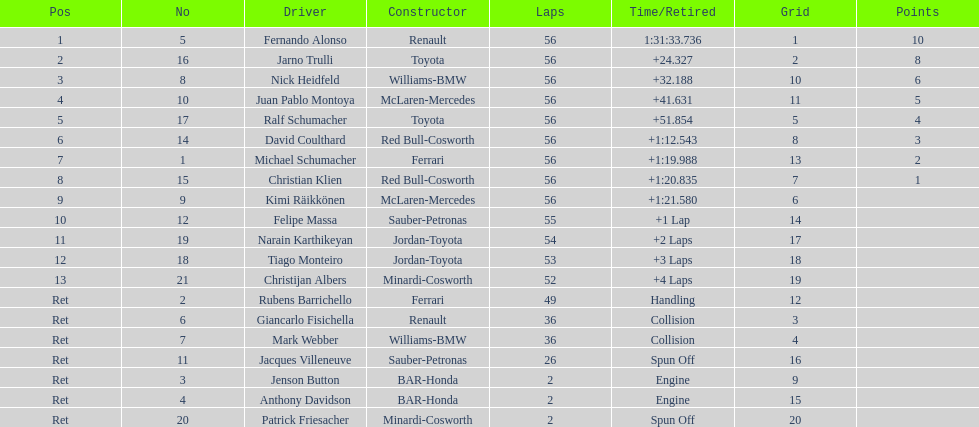How many bmws finished before webber? 1. Give me the full table as a dictionary. {'header': ['Pos', 'No', 'Driver', 'Constructor', 'Laps', 'Time/Retired', 'Grid', 'Points'], 'rows': [['1', '5', 'Fernando Alonso', 'Renault', '56', '1:31:33.736', '1', '10'], ['2', '16', 'Jarno Trulli', 'Toyota', '56', '+24.327', '2', '8'], ['3', '8', 'Nick Heidfeld', 'Williams-BMW', '56', '+32.188', '10', '6'], ['4', '10', 'Juan Pablo Montoya', 'McLaren-Mercedes', '56', '+41.631', '11', '5'], ['5', '17', 'Ralf Schumacher', 'Toyota', '56', '+51.854', '5', '4'], ['6', '14', 'David Coulthard', 'Red Bull-Cosworth', '56', '+1:12.543', '8', '3'], ['7', '1', 'Michael Schumacher', 'Ferrari', '56', '+1:19.988', '13', '2'], ['8', '15', 'Christian Klien', 'Red Bull-Cosworth', '56', '+1:20.835', '7', '1'], ['9', '9', 'Kimi Räikkönen', 'McLaren-Mercedes', '56', '+1:21.580', '6', ''], ['10', '12', 'Felipe Massa', 'Sauber-Petronas', '55', '+1 Lap', '14', ''], ['11', '19', 'Narain Karthikeyan', 'Jordan-Toyota', '54', '+2 Laps', '17', ''], ['12', '18', 'Tiago Monteiro', 'Jordan-Toyota', '53', '+3 Laps', '18', ''], ['13', '21', 'Christijan Albers', 'Minardi-Cosworth', '52', '+4 Laps', '19', ''], ['Ret', '2', 'Rubens Barrichello', 'Ferrari', '49', 'Handling', '12', ''], ['Ret', '6', 'Giancarlo Fisichella', 'Renault', '36', 'Collision', '3', ''], ['Ret', '7', 'Mark Webber', 'Williams-BMW', '36', 'Collision', '4', ''], ['Ret', '11', 'Jacques Villeneuve', 'Sauber-Petronas', '26', 'Spun Off', '16', ''], ['Ret', '3', 'Jenson Button', 'BAR-Honda', '2', 'Engine', '9', ''], ['Ret', '4', 'Anthony Davidson', 'BAR-Honda', '2', 'Engine', '15', ''], ['Ret', '20', 'Patrick Friesacher', 'Minardi-Cosworth', '2', 'Spun Off', '20', '']]} 